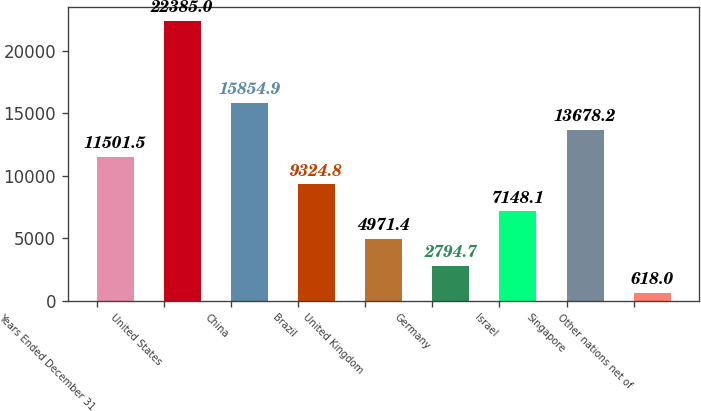Convert chart. <chart><loc_0><loc_0><loc_500><loc_500><bar_chart><fcel>Years Ended December 31<fcel>United States<fcel>China<fcel>Brazil<fcel>United Kingdom<fcel>Germany<fcel>Israel<fcel>Singapore<fcel>Other nations net of<nl><fcel>11501.5<fcel>22385<fcel>15854.9<fcel>9324.8<fcel>4971.4<fcel>2794.7<fcel>7148.1<fcel>13678.2<fcel>618<nl></chart> 